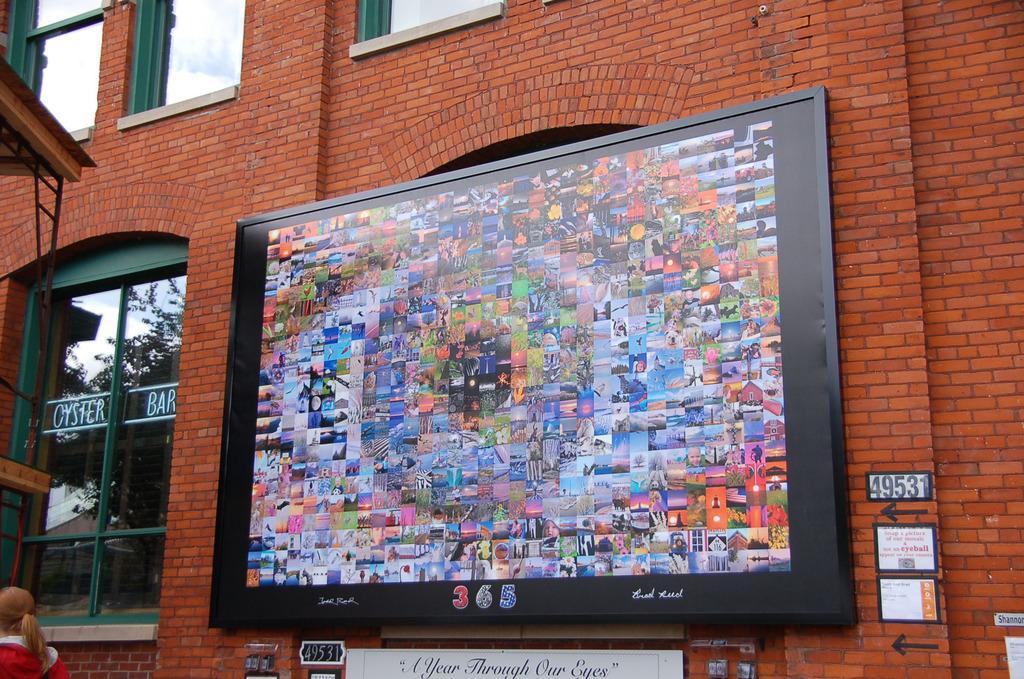Describe this image in one or two sentences. In this image I can see a building wall, hoarding, windows and a person. This image is taken during a day near the restaurant. 